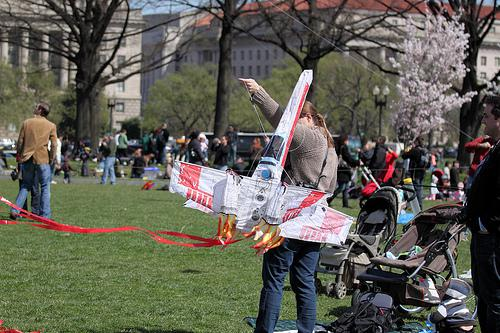Question: what is the woman in the foreground holding?
Choices:
A. A balloon.
B. A flower.
C. A string.
D. A kite.
Answer with the letter. Answer: D Question: who rides in the strollers?
Choices:
A. Dolls.
B. Babies.
C. Dogs.
D. Cats.
Answer with the letter. Answer: B Question: what is this photo's setting?
Choices:
A. A park.
B. A beach.
C. A sports arena.
D. A mall.
Answer with the letter. Answer: A Question: how do kites fly?
Choices:
A. Via wind.
B. In the sky.
C. On a line of string.
D. Via the internet.
Answer with the letter. Answer: A Question: what season was this held during?
Choices:
A. Summer.
B. Winter.
C. Spring.
D. Fall.
Answer with the letter. Answer: C 